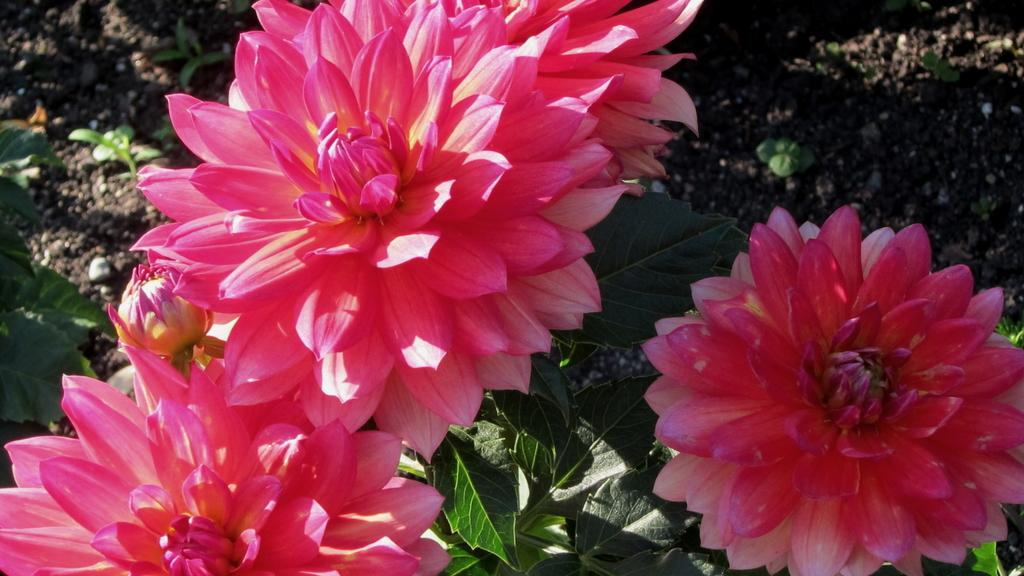What type of plants can be seen in the image? There are flowers in the image. What color are the flowers? The flowers are pink in color. What else can be seen below the flowers in the image? There are leaves below the flowers in the image. What type of bag is hanging from the zinc roof in the image? There is no bag or zinc roof present in the image; it features flowers and leaves. 